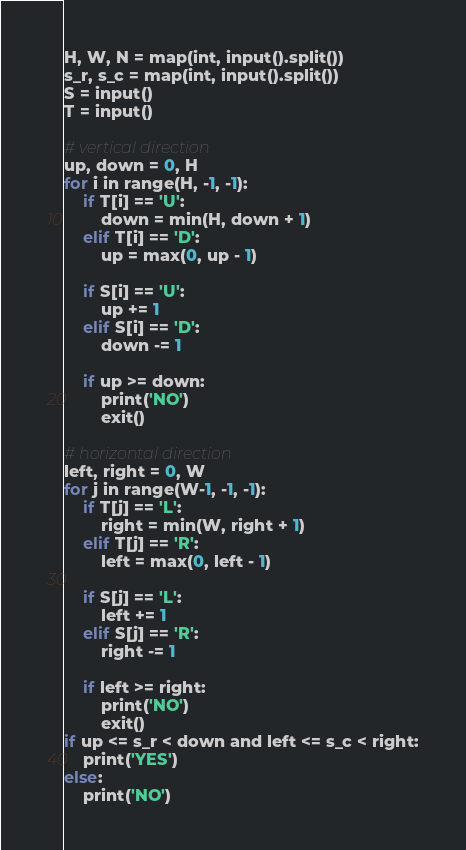<code> <loc_0><loc_0><loc_500><loc_500><_Python_>H, W, N = map(int, input().split())
s_r, s_c = map(int, input().split())
S = input()
T = input()

# vertical direction
up, down = 0, H
for i in range(H, -1, -1):
    if T[i] == 'U':
        down = min(H, down + 1)
    elif T[i] == 'D':
        up = max(0, up - 1)
    
    if S[i] == 'U':
        up += 1
    elif S[i] == 'D':
        down -= 1
    
    if up >= down:
        print('NO')
        exit()
        
# horizontal direction
left, right = 0, W
for j in range(W-1, -1, -1):    
    if T[j] == 'L':
        right = min(W, right + 1)
    elif T[j] == 'R':
        left = max(0, left - 1)
    
    if S[j] == 'L':
        left += 1
    elif S[j] == 'R':
        right -= 1
    
    if left >= right:
        print('NO')
        exit()
if up <= s_r < down and left <= s_c < right:
    print('YES')
else:
    print('NO')</code> 